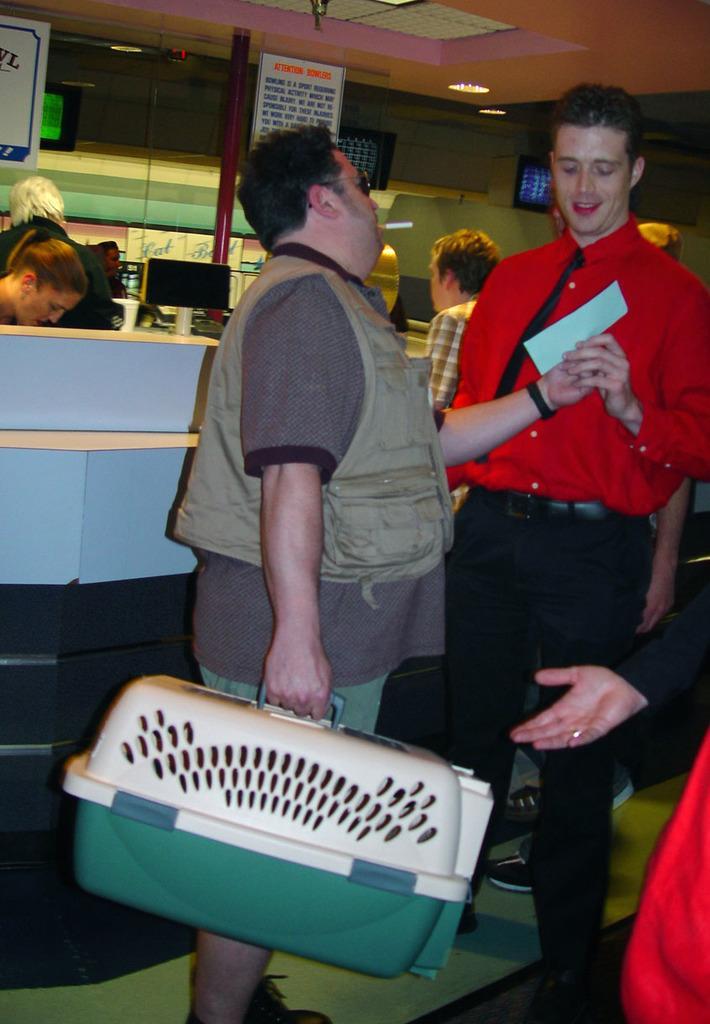Describe this image in one or two sentences. In this image there are people standing one man is holding a box in his hand, in the background there is a counter in that counter there are people standing and there is a wall, at the top there is a ceiling and lights. 